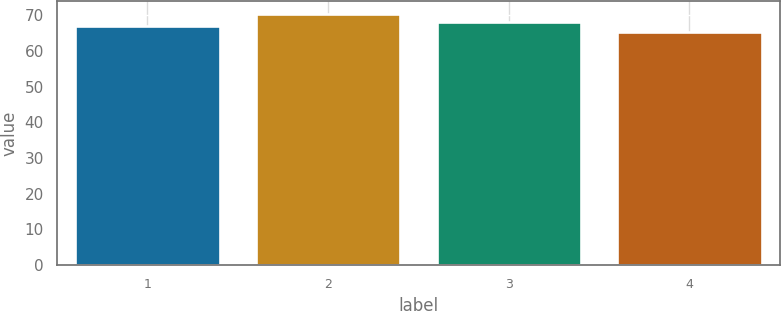Convert chart to OTSL. <chart><loc_0><loc_0><loc_500><loc_500><bar_chart><fcel>1<fcel>2<fcel>3<fcel>4<nl><fcel>66.87<fcel>70.32<fcel>68.14<fcel>65.16<nl></chart> 